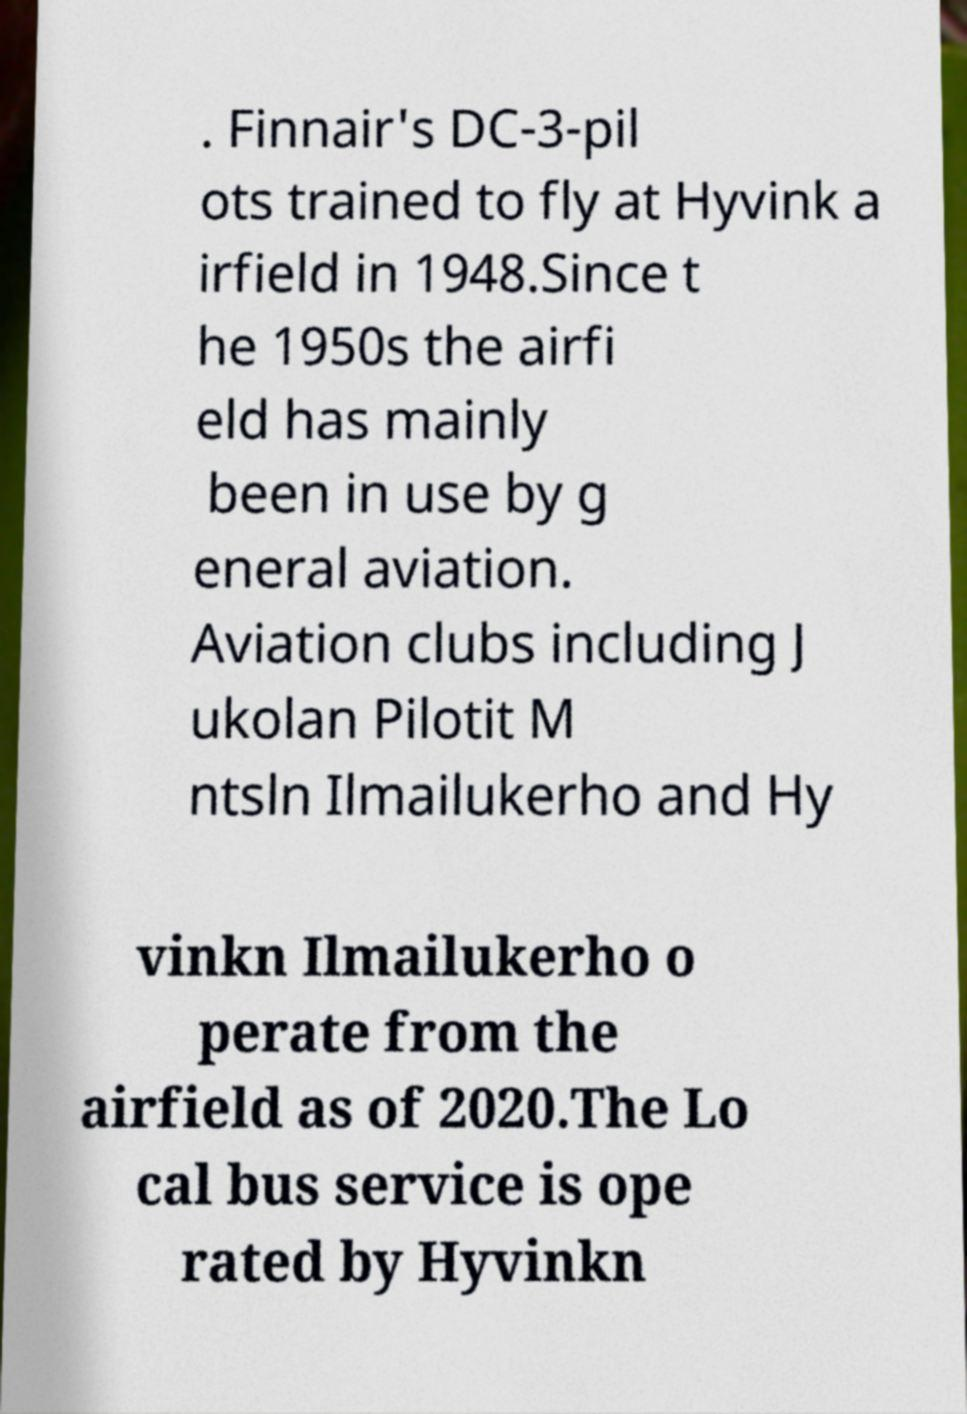Can you read and provide the text displayed in the image?This photo seems to have some interesting text. Can you extract and type it out for me? . Finnair's DC-3-pil ots trained to fly at Hyvink a irfield in 1948.Since t he 1950s the airfi eld has mainly been in use by g eneral aviation. Aviation clubs including J ukolan Pilotit M ntsln Ilmailukerho and Hy vinkn Ilmailukerho o perate from the airfield as of 2020.The Lo cal bus service is ope rated by Hyvinkn 